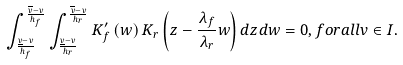Convert formula to latex. <formula><loc_0><loc_0><loc_500><loc_500>\int _ { \frac { \underline { v } - v } { h _ { f } } } ^ { \frac { \overline { v } - v } { h _ { f } } } \int _ { \frac { \underline { v } - v } { h _ { r } } } ^ { \frac { \overline { v } - v } { h _ { r } } } K _ { f } ^ { \prime } \left ( w \right ) K _ { r } \left ( z - \frac { \lambda _ { f } } { \lambda _ { r } } w \right ) d z d w = 0 , f o r a l l { v \in I } .</formula> 